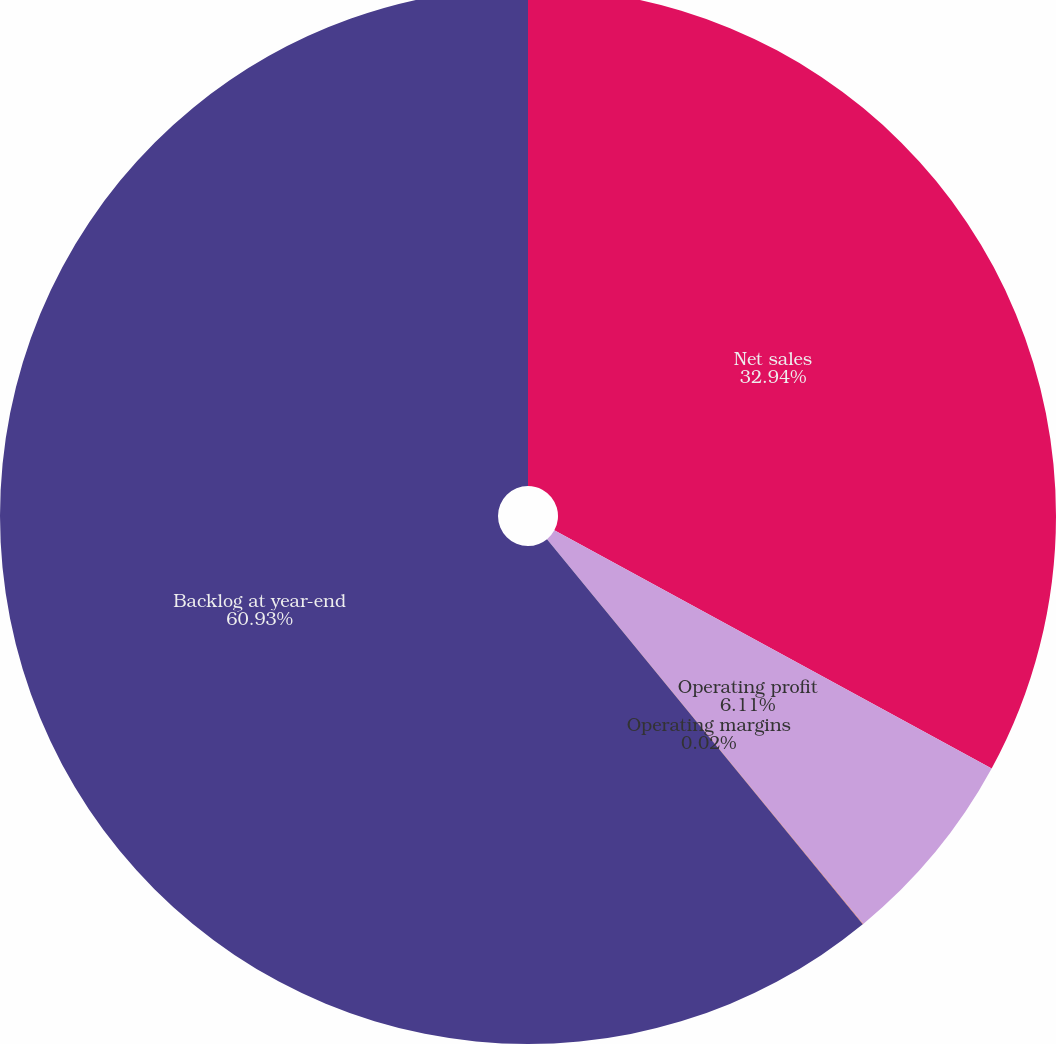<chart> <loc_0><loc_0><loc_500><loc_500><pie_chart><fcel>Net sales<fcel>Operating profit<fcel>Operating margins<fcel>Backlog at year-end<nl><fcel>32.94%<fcel>6.11%<fcel>0.02%<fcel>60.93%<nl></chart> 